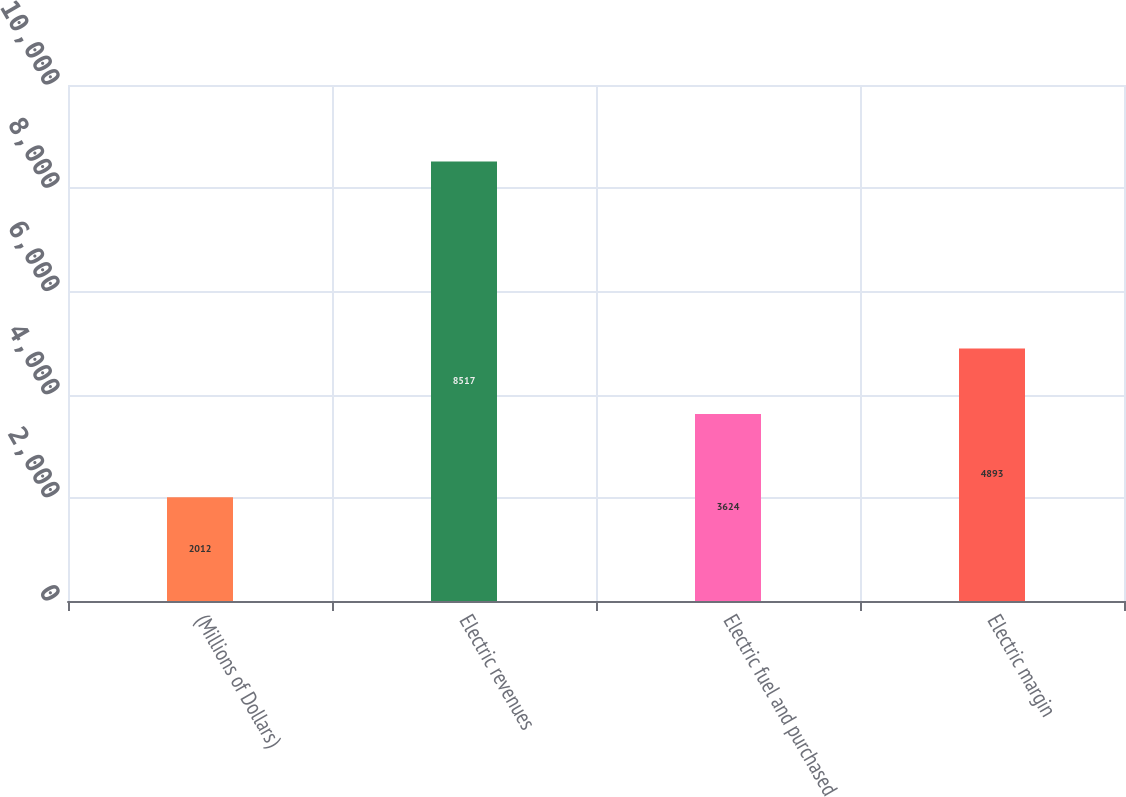Convert chart. <chart><loc_0><loc_0><loc_500><loc_500><bar_chart><fcel>(Millions of Dollars)<fcel>Electric revenues<fcel>Electric fuel and purchased<fcel>Electric margin<nl><fcel>2012<fcel>8517<fcel>3624<fcel>4893<nl></chart> 